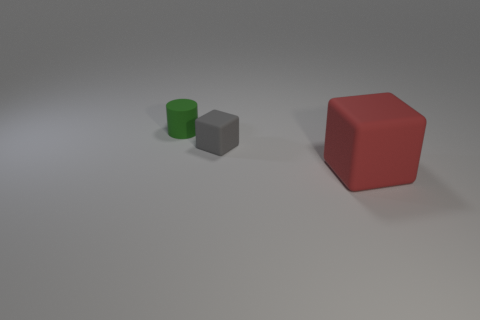How does the size of the grey cube compare to the green cylinder? The grey cube appears to be relatively smaller in size when compared with the green cylinder, which looks taller and has a wider base, indicating that the green cylinder has larger dimensions overall. 